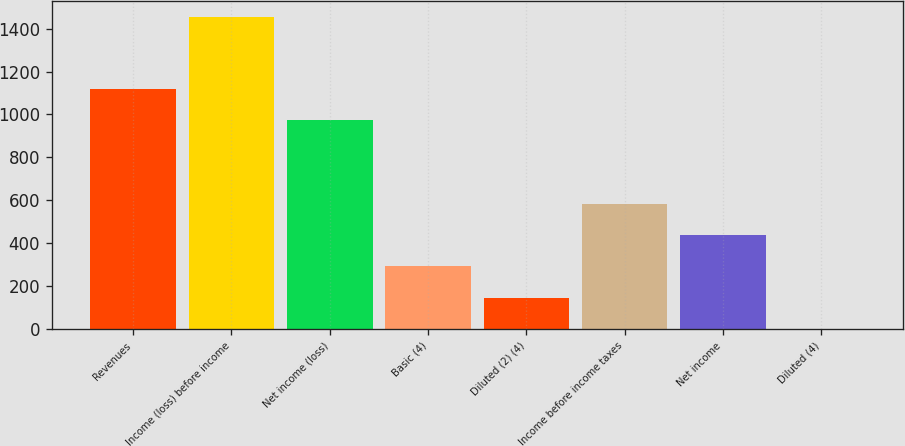Convert chart to OTSL. <chart><loc_0><loc_0><loc_500><loc_500><bar_chart><fcel>Revenues<fcel>Income (loss) before income<fcel>Net income (loss)<fcel>Basic (4)<fcel>Diluted (2) (4)<fcel>Income before income taxes<fcel>Net income<fcel>Diluted (4)<nl><fcel>1119.27<fcel>1454<fcel>974<fcel>291.82<fcel>146.55<fcel>582.36<fcel>437.09<fcel>1.28<nl></chart> 